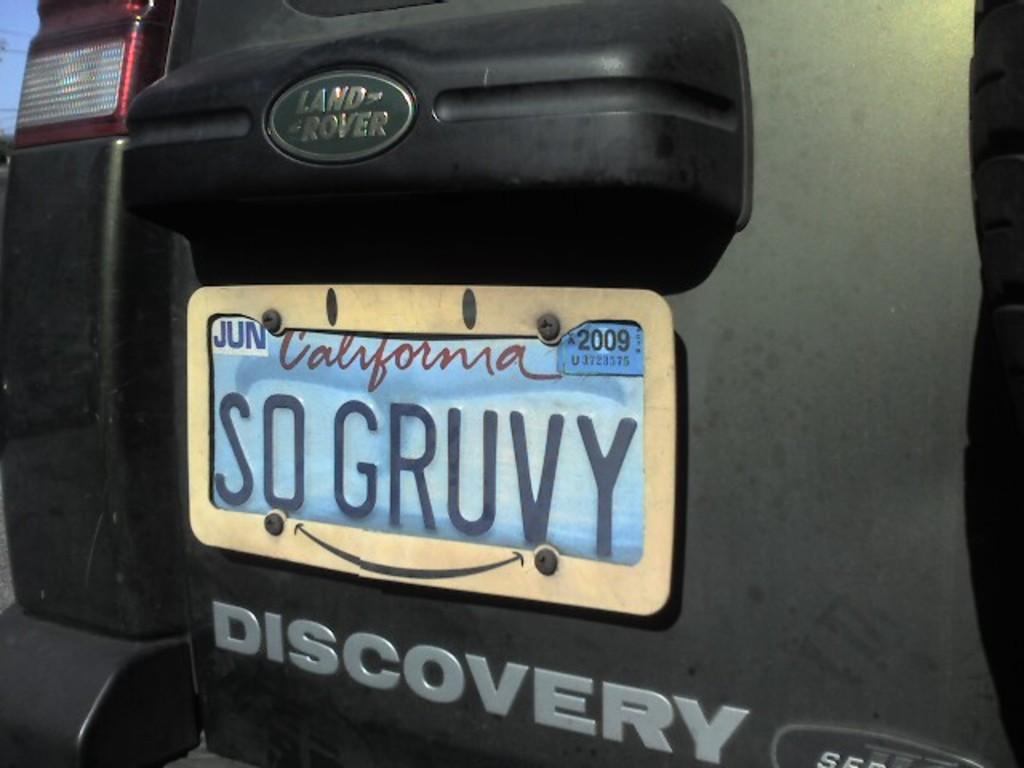<image>
Render a clear and concise summary of the photo. The back of a Discover Land Rover with a California license plate that reads SD GRUVY. 